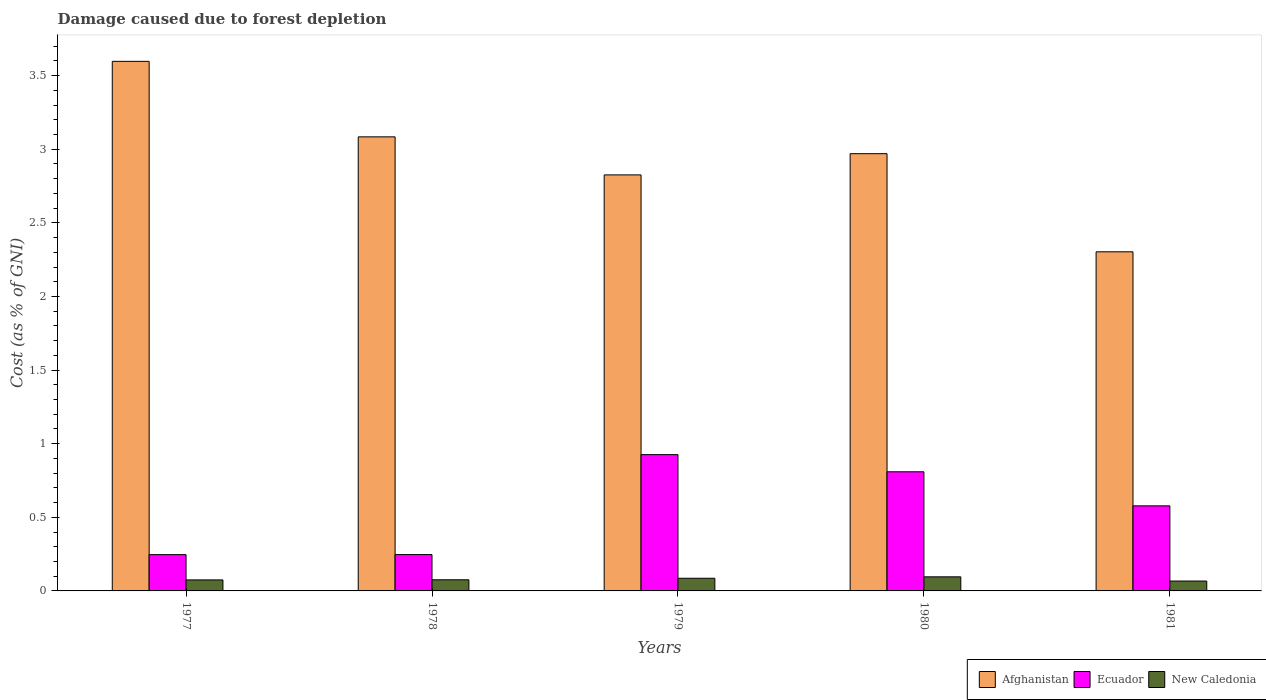What is the label of the 4th group of bars from the left?
Provide a succinct answer. 1980. In how many cases, is the number of bars for a given year not equal to the number of legend labels?
Your response must be concise. 0. What is the cost of damage caused due to forest depletion in New Caledonia in 1981?
Your answer should be compact. 0.07. Across all years, what is the maximum cost of damage caused due to forest depletion in Ecuador?
Ensure brevity in your answer.  0.93. Across all years, what is the minimum cost of damage caused due to forest depletion in Ecuador?
Keep it short and to the point. 0.25. What is the total cost of damage caused due to forest depletion in Ecuador in the graph?
Offer a terse response. 2.81. What is the difference between the cost of damage caused due to forest depletion in New Caledonia in 1977 and that in 1980?
Ensure brevity in your answer.  -0.02. What is the difference between the cost of damage caused due to forest depletion in Ecuador in 1978 and the cost of damage caused due to forest depletion in Afghanistan in 1980?
Your answer should be compact. -2.72. What is the average cost of damage caused due to forest depletion in Ecuador per year?
Offer a very short reply. 0.56. In the year 1980, what is the difference between the cost of damage caused due to forest depletion in Afghanistan and cost of damage caused due to forest depletion in Ecuador?
Your answer should be very brief. 2.16. In how many years, is the cost of damage caused due to forest depletion in Ecuador greater than 0.6 %?
Your response must be concise. 2. What is the ratio of the cost of damage caused due to forest depletion in Ecuador in 1977 to that in 1979?
Provide a succinct answer. 0.27. Is the difference between the cost of damage caused due to forest depletion in Afghanistan in 1978 and 1981 greater than the difference between the cost of damage caused due to forest depletion in Ecuador in 1978 and 1981?
Provide a succinct answer. Yes. What is the difference between the highest and the second highest cost of damage caused due to forest depletion in New Caledonia?
Keep it short and to the point. 0.01. What is the difference between the highest and the lowest cost of damage caused due to forest depletion in New Caledonia?
Your response must be concise. 0.03. What does the 1st bar from the left in 1977 represents?
Provide a short and direct response. Afghanistan. What does the 2nd bar from the right in 1977 represents?
Your answer should be compact. Ecuador. Is it the case that in every year, the sum of the cost of damage caused due to forest depletion in Afghanistan and cost of damage caused due to forest depletion in Ecuador is greater than the cost of damage caused due to forest depletion in New Caledonia?
Offer a very short reply. Yes. How many bars are there?
Offer a very short reply. 15. Are all the bars in the graph horizontal?
Offer a very short reply. No. What is the difference between two consecutive major ticks on the Y-axis?
Your response must be concise. 0.5. Are the values on the major ticks of Y-axis written in scientific E-notation?
Offer a terse response. No. Does the graph contain any zero values?
Your answer should be compact. No. How many legend labels are there?
Provide a short and direct response. 3. What is the title of the graph?
Your response must be concise. Damage caused due to forest depletion. What is the label or title of the Y-axis?
Ensure brevity in your answer.  Cost (as % of GNI). What is the Cost (as % of GNI) in Afghanistan in 1977?
Provide a short and direct response. 3.6. What is the Cost (as % of GNI) in Ecuador in 1977?
Your response must be concise. 0.25. What is the Cost (as % of GNI) in New Caledonia in 1977?
Provide a short and direct response. 0.07. What is the Cost (as % of GNI) in Afghanistan in 1978?
Offer a very short reply. 3.08. What is the Cost (as % of GNI) in Ecuador in 1978?
Make the answer very short. 0.25. What is the Cost (as % of GNI) in New Caledonia in 1978?
Offer a very short reply. 0.08. What is the Cost (as % of GNI) in Afghanistan in 1979?
Provide a succinct answer. 2.83. What is the Cost (as % of GNI) of Ecuador in 1979?
Keep it short and to the point. 0.93. What is the Cost (as % of GNI) in New Caledonia in 1979?
Give a very brief answer. 0.09. What is the Cost (as % of GNI) in Afghanistan in 1980?
Provide a short and direct response. 2.97. What is the Cost (as % of GNI) in Ecuador in 1980?
Your response must be concise. 0.81. What is the Cost (as % of GNI) of New Caledonia in 1980?
Offer a very short reply. 0.1. What is the Cost (as % of GNI) in Afghanistan in 1981?
Your response must be concise. 2.3. What is the Cost (as % of GNI) in Ecuador in 1981?
Give a very brief answer. 0.58. What is the Cost (as % of GNI) in New Caledonia in 1981?
Keep it short and to the point. 0.07. Across all years, what is the maximum Cost (as % of GNI) in Afghanistan?
Give a very brief answer. 3.6. Across all years, what is the maximum Cost (as % of GNI) of Ecuador?
Keep it short and to the point. 0.93. Across all years, what is the maximum Cost (as % of GNI) of New Caledonia?
Ensure brevity in your answer.  0.1. Across all years, what is the minimum Cost (as % of GNI) in Afghanistan?
Make the answer very short. 2.3. Across all years, what is the minimum Cost (as % of GNI) in Ecuador?
Offer a very short reply. 0.25. Across all years, what is the minimum Cost (as % of GNI) of New Caledonia?
Your response must be concise. 0.07. What is the total Cost (as % of GNI) of Afghanistan in the graph?
Offer a very short reply. 14.78. What is the total Cost (as % of GNI) of Ecuador in the graph?
Your answer should be very brief. 2.81. What is the total Cost (as % of GNI) in New Caledonia in the graph?
Provide a short and direct response. 0.4. What is the difference between the Cost (as % of GNI) of Afghanistan in 1977 and that in 1978?
Make the answer very short. 0.51. What is the difference between the Cost (as % of GNI) of Ecuador in 1977 and that in 1978?
Make the answer very short. -0. What is the difference between the Cost (as % of GNI) in New Caledonia in 1977 and that in 1978?
Offer a terse response. -0. What is the difference between the Cost (as % of GNI) of Afghanistan in 1977 and that in 1979?
Give a very brief answer. 0.77. What is the difference between the Cost (as % of GNI) of Ecuador in 1977 and that in 1979?
Ensure brevity in your answer.  -0.68. What is the difference between the Cost (as % of GNI) of New Caledonia in 1977 and that in 1979?
Make the answer very short. -0.01. What is the difference between the Cost (as % of GNI) in Afghanistan in 1977 and that in 1980?
Your response must be concise. 0.63. What is the difference between the Cost (as % of GNI) in Ecuador in 1977 and that in 1980?
Your answer should be compact. -0.56. What is the difference between the Cost (as % of GNI) of New Caledonia in 1977 and that in 1980?
Offer a very short reply. -0.02. What is the difference between the Cost (as % of GNI) in Afghanistan in 1977 and that in 1981?
Give a very brief answer. 1.29. What is the difference between the Cost (as % of GNI) of Ecuador in 1977 and that in 1981?
Provide a short and direct response. -0.33. What is the difference between the Cost (as % of GNI) in New Caledonia in 1977 and that in 1981?
Make the answer very short. 0.01. What is the difference between the Cost (as % of GNI) in Afghanistan in 1978 and that in 1979?
Your answer should be compact. 0.26. What is the difference between the Cost (as % of GNI) of Ecuador in 1978 and that in 1979?
Your response must be concise. -0.68. What is the difference between the Cost (as % of GNI) of New Caledonia in 1978 and that in 1979?
Provide a short and direct response. -0.01. What is the difference between the Cost (as % of GNI) in Afghanistan in 1978 and that in 1980?
Ensure brevity in your answer.  0.11. What is the difference between the Cost (as % of GNI) of Ecuador in 1978 and that in 1980?
Your answer should be compact. -0.56. What is the difference between the Cost (as % of GNI) of New Caledonia in 1978 and that in 1980?
Give a very brief answer. -0.02. What is the difference between the Cost (as % of GNI) in Afghanistan in 1978 and that in 1981?
Provide a succinct answer. 0.78. What is the difference between the Cost (as % of GNI) of Ecuador in 1978 and that in 1981?
Your response must be concise. -0.33. What is the difference between the Cost (as % of GNI) of New Caledonia in 1978 and that in 1981?
Your answer should be compact. 0.01. What is the difference between the Cost (as % of GNI) of Afghanistan in 1979 and that in 1980?
Your answer should be compact. -0.14. What is the difference between the Cost (as % of GNI) of Ecuador in 1979 and that in 1980?
Ensure brevity in your answer.  0.12. What is the difference between the Cost (as % of GNI) in New Caledonia in 1979 and that in 1980?
Your answer should be compact. -0.01. What is the difference between the Cost (as % of GNI) in Afghanistan in 1979 and that in 1981?
Ensure brevity in your answer.  0.52. What is the difference between the Cost (as % of GNI) of Ecuador in 1979 and that in 1981?
Keep it short and to the point. 0.35. What is the difference between the Cost (as % of GNI) in New Caledonia in 1979 and that in 1981?
Your answer should be very brief. 0.02. What is the difference between the Cost (as % of GNI) of Afghanistan in 1980 and that in 1981?
Offer a very short reply. 0.67. What is the difference between the Cost (as % of GNI) in Ecuador in 1980 and that in 1981?
Your answer should be compact. 0.23. What is the difference between the Cost (as % of GNI) in New Caledonia in 1980 and that in 1981?
Ensure brevity in your answer.  0.03. What is the difference between the Cost (as % of GNI) of Afghanistan in 1977 and the Cost (as % of GNI) of Ecuador in 1978?
Provide a short and direct response. 3.35. What is the difference between the Cost (as % of GNI) of Afghanistan in 1977 and the Cost (as % of GNI) of New Caledonia in 1978?
Make the answer very short. 3.52. What is the difference between the Cost (as % of GNI) of Ecuador in 1977 and the Cost (as % of GNI) of New Caledonia in 1978?
Ensure brevity in your answer.  0.17. What is the difference between the Cost (as % of GNI) of Afghanistan in 1977 and the Cost (as % of GNI) of Ecuador in 1979?
Keep it short and to the point. 2.67. What is the difference between the Cost (as % of GNI) in Afghanistan in 1977 and the Cost (as % of GNI) in New Caledonia in 1979?
Provide a short and direct response. 3.51. What is the difference between the Cost (as % of GNI) in Ecuador in 1977 and the Cost (as % of GNI) in New Caledonia in 1979?
Your answer should be compact. 0.16. What is the difference between the Cost (as % of GNI) in Afghanistan in 1977 and the Cost (as % of GNI) in Ecuador in 1980?
Your response must be concise. 2.79. What is the difference between the Cost (as % of GNI) in Afghanistan in 1977 and the Cost (as % of GNI) in New Caledonia in 1980?
Your answer should be very brief. 3.5. What is the difference between the Cost (as % of GNI) in Ecuador in 1977 and the Cost (as % of GNI) in New Caledonia in 1980?
Your answer should be very brief. 0.15. What is the difference between the Cost (as % of GNI) of Afghanistan in 1977 and the Cost (as % of GNI) of Ecuador in 1981?
Your answer should be compact. 3.02. What is the difference between the Cost (as % of GNI) of Afghanistan in 1977 and the Cost (as % of GNI) of New Caledonia in 1981?
Your answer should be compact. 3.53. What is the difference between the Cost (as % of GNI) of Ecuador in 1977 and the Cost (as % of GNI) of New Caledonia in 1981?
Your response must be concise. 0.18. What is the difference between the Cost (as % of GNI) in Afghanistan in 1978 and the Cost (as % of GNI) in Ecuador in 1979?
Your answer should be compact. 2.16. What is the difference between the Cost (as % of GNI) in Afghanistan in 1978 and the Cost (as % of GNI) in New Caledonia in 1979?
Give a very brief answer. 3. What is the difference between the Cost (as % of GNI) in Ecuador in 1978 and the Cost (as % of GNI) in New Caledonia in 1979?
Your answer should be compact. 0.16. What is the difference between the Cost (as % of GNI) of Afghanistan in 1978 and the Cost (as % of GNI) of Ecuador in 1980?
Keep it short and to the point. 2.27. What is the difference between the Cost (as % of GNI) in Afghanistan in 1978 and the Cost (as % of GNI) in New Caledonia in 1980?
Your response must be concise. 2.99. What is the difference between the Cost (as % of GNI) of Ecuador in 1978 and the Cost (as % of GNI) of New Caledonia in 1980?
Offer a very short reply. 0.15. What is the difference between the Cost (as % of GNI) in Afghanistan in 1978 and the Cost (as % of GNI) in Ecuador in 1981?
Offer a very short reply. 2.51. What is the difference between the Cost (as % of GNI) of Afghanistan in 1978 and the Cost (as % of GNI) of New Caledonia in 1981?
Keep it short and to the point. 3.02. What is the difference between the Cost (as % of GNI) in Ecuador in 1978 and the Cost (as % of GNI) in New Caledonia in 1981?
Your response must be concise. 0.18. What is the difference between the Cost (as % of GNI) in Afghanistan in 1979 and the Cost (as % of GNI) in Ecuador in 1980?
Ensure brevity in your answer.  2.02. What is the difference between the Cost (as % of GNI) in Afghanistan in 1979 and the Cost (as % of GNI) in New Caledonia in 1980?
Your response must be concise. 2.73. What is the difference between the Cost (as % of GNI) in Ecuador in 1979 and the Cost (as % of GNI) in New Caledonia in 1980?
Offer a very short reply. 0.83. What is the difference between the Cost (as % of GNI) in Afghanistan in 1979 and the Cost (as % of GNI) in Ecuador in 1981?
Provide a succinct answer. 2.25. What is the difference between the Cost (as % of GNI) of Afghanistan in 1979 and the Cost (as % of GNI) of New Caledonia in 1981?
Keep it short and to the point. 2.76. What is the difference between the Cost (as % of GNI) of Ecuador in 1979 and the Cost (as % of GNI) of New Caledonia in 1981?
Make the answer very short. 0.86. What is the difference between the Cost (as % of GNI) of Afghanistan in 1980 and the Cost (as % of GNI) of Ecuador in 1981?
Your answer should be compact. 2.39. What is the difference between the Cost (as % of GNI) of Afghanistan in 1980 and the Cost (as % of GNI) of New Caledonia in 1981?
Offer a terse response. 2.9. What is the difference between the Cost (as % of GNI) of Ecuador in 1980 and the Cost (as % of GNI) of New Caledonia in 1981?
Provide a succinct answer. 0.74. What is the average Cost (as % of GNI) of Afghanistan per year?
Give a very brief answer. 2.96. What is the average Cost (as % of GNI) of Ecuador per year?
Make the answer very short. 0.56. What is the average Cost (as % of GNI) in New Caledonia per year?
Your answer should be compact. 0.08. In the year 1977, what is the difference between the Cost (as % of GNI) of Afghanistan and Cost (as % of GNI) of Ecuador?
Give a very brief answer. 3.35. In the year 1977, what is the difference between the Cost (as % of GNI) of Afghanistan and Cost (as % of GNI) of New Caledonia?
Give a very brief answer. 3.52. In the year 1977, what is the difference between the Cost (as % of GNI) of Ecuador and Cost (as % of GNI) of New Caledonia?
Give a very brief answer. 0.17. In the year 1978, what is the difference between the Cost (as % of GNI) of Afghanistan and Cost (as % of GNI) of Ecuador?
Provide a short and direct response. 2.84. In the year 1978, what is the difference between the Cost (as % of GNI) in Afghanistan and Cost (as % of GNI) in New Caledonia?
Offer a very short reply. 3.01. In the year 1978, what is the difference between the Cost (as % of GNI) of Ecuador and Cost (as % of GNI) of New Caledonia?
Your response must be concise. 0.17. In the year 1979, what is the difference between the Cost (as % of GNI) in Afghanistan and Cost (as % of GNI) in Ecuador?
Your answer should be compact. 1.9. In the year 1979, what is the difference between the Cost (as % of GNI) in Afghanistan and Cost (as % of GNI) in New Caledonia?
Your answer should be very brief. 2.74. In the year 1979, what is the difference between the Cost (as % of GNI) in Ecuador and Cost (as % of GNI) in New Caledonia?
Ensure brevity in your answer.  0.84. In the year 1980, what is the difference between the Cost (as % of GNI) in Afghanistan and Cost (as % of GNI) in Ecuador?
Your answer should be compact. 2.16. In the year 1980, what is the difference between the Cost (as % of GNI) of Afghanistan and Cost (as % of GNI) of New Caledonia?
Make the answer very short. 2.87. In the year 1980, what is the difference between the Cost (as % of GNI) of Ecuador and Cost (as % of GNI) of New Caledonia?
Your answer should be compact. 0.71. In the year 1981, what is the difference between the Cost (as % of GNI) in Afghanistan and Cost (as % of GNI) in Ecuador?
Give a very brief answer. 1.73. In the year 1981, what is the difference between the Cost (as % of GNI) of Afghanistan and Cost (as % of GNI) of New Caledonia?
Your response must be concise. 2.24. In the year 1981, what is the difference between the Cost (as % of GNI) of Ecuador and Cost (as % of GNI) of New Caledonia?
Give a very brief answer. 0.51. What is the ratio of the Cost (as % of GNI) of Afghanistan in 1977 to that in 1978?
Offer a very short reply. 1.17. What is the ratio of the Cost (as % of GNI) of New Caledonia in 1977 to that in 1978?
Your response must be concise. 0.99. What is the ratio of the Cost (as % of GNI) of Afghanistan in 1977 to that in 1979?
Make the answer very short. 1.27. What is the ratio of the Cost (as % of GNI) in Ecuador in 1977 to that in 1979?
Provide a short and direct response. 0.27. What is the ratio of the Cost (as % of GNI) in New Caledonia in 1977 to that in 1979?
Make the answer very short. 0.87. What is the ratio of the Cost (as % of GNI) in Afghanistan in 1977 to that in 1980?
Provide a succinct answer. 1.21. What is the ratio of the Cost (as % of GNI) in Ecuador in 1977 to that in 1980?
Your answer should be very brief. 0.3. What is the ratio of the Cost (as % of GNI) of New Caledonia in 1977 to that in 1980?
Give a very brief answer. 0.78. What is the ratio of the Cost (as % of GNI) of Afghanistan in 1977 to that in 1981?
Your answer should be very brief. 1.56. What is the ratio of the Cost (as % of GNI) of Ecuador in 1977 to that in 1981?
Provide a succinct answer. 0.43. What is the ratio of the Cost (as % of GNI) of New Caledonia in 1977 to that in 1981?
Give a very brief answer. 1.11. What is the ratio of the Cost (as % of GNI) in Afghanistan in 1978 to that in 1979?
Provide a succinct answer. 1.09. What is the ratio of the Cost (as % of GNI) of Ecuador in 1978 to that in 1979?
Keep it short and to the point. 0.27. What is the ratio of the Cost (as % of GNI) in New Caledonia in 1978 to that in 1979?
Your response must be concise. 0.88. What is the ratio of the Cost (as % of GNI) of Ecuador in 1978 to that in 1980?
Provide a succinct answer. 0.3. What is the ratio of the Cost (as % of GNI) of New Caledonia in 1978 to that in 1980?
Make the answer very short. 0.79. What is the ratio of the Cost (as % of GNI) in Afghanistan in 1978 to that in 1981?
Ensure brevity in your answer.  1.34. What is the ratio of the Cost (as % of GNI) of Ecuador in 1978 to that in 1981?
Keep it short and to the point. 0.43. What is the ratio of the Cost (as % of GNI) of New Caledonia in 1978 to that in 1981?
Give a very brief answer. 1.13. What is the ratio of the Cost (as % of GNI) of Afghanistan in 1979 to that in 1980?
Make the answer very short. 0.95. What is the ratio of the Cost (as % of GNI) in Ecuador in 1979 to that in 1980?
Make the answer very short. 1.14. What is the ratio of the Cost (as % of GNI) of New Caledonia in 1979 to that in 1980?
Offer a very short reply. 0.9. What is the ratio of the Cost (as % of GNI) of Afghanistan in 1979 to that in 1981?
Ensure brevity in your answer.  1.23. What is the ratio of the Cost (as % of GNI) in Ecuador in 1979 to that in 1981?
Offer a terse response. 1.6. What is the ratio of the Cost (as % of GNI) in New Caledonia in 1979 to that in 1981?
Provide a short and direct response. 1.28. What is the ratio of the Cost (as % of GNI) of Afghanistan in 1980 to that in 1981?
Provide a succinct answer. 1.29. What is the ratio of the Cost (as % of GNI) in Ecuador in 1980 to that in 1981?
Give a very brief answer. 1.4. What is the ratio of the Cost (as % of GNI) in New Caledonia in 1980 to that in 1981?
Offer a very short reply. 1.43. What is the difference between the highest and the second highest Cost (as % of GNI) in Afghanistan?
Make the answer very short. 0.51. What is the difference between the highest and the second highest Cost (as % of GNI) of Ecuador?
Ensure brevity in your answer.  0.12. What is the difference between the highest and the second highest Cost (as % of GNI) in New Caledonia?
Offer a very short reply. 0.01. What is the difference between the highest and the lowest Cost (as % of GNI) in Afghanistan?
Provide a succinct answer. 1.29. What is the difference between the highest and the lowest Cost (as % of GNI) in Ecuador?
Give a very brief answer. 0.68. What is the difference between the highest and the lowest Cost (as % of GNI) in New Caledonia?
Keep it short and to the point. 0.03. 